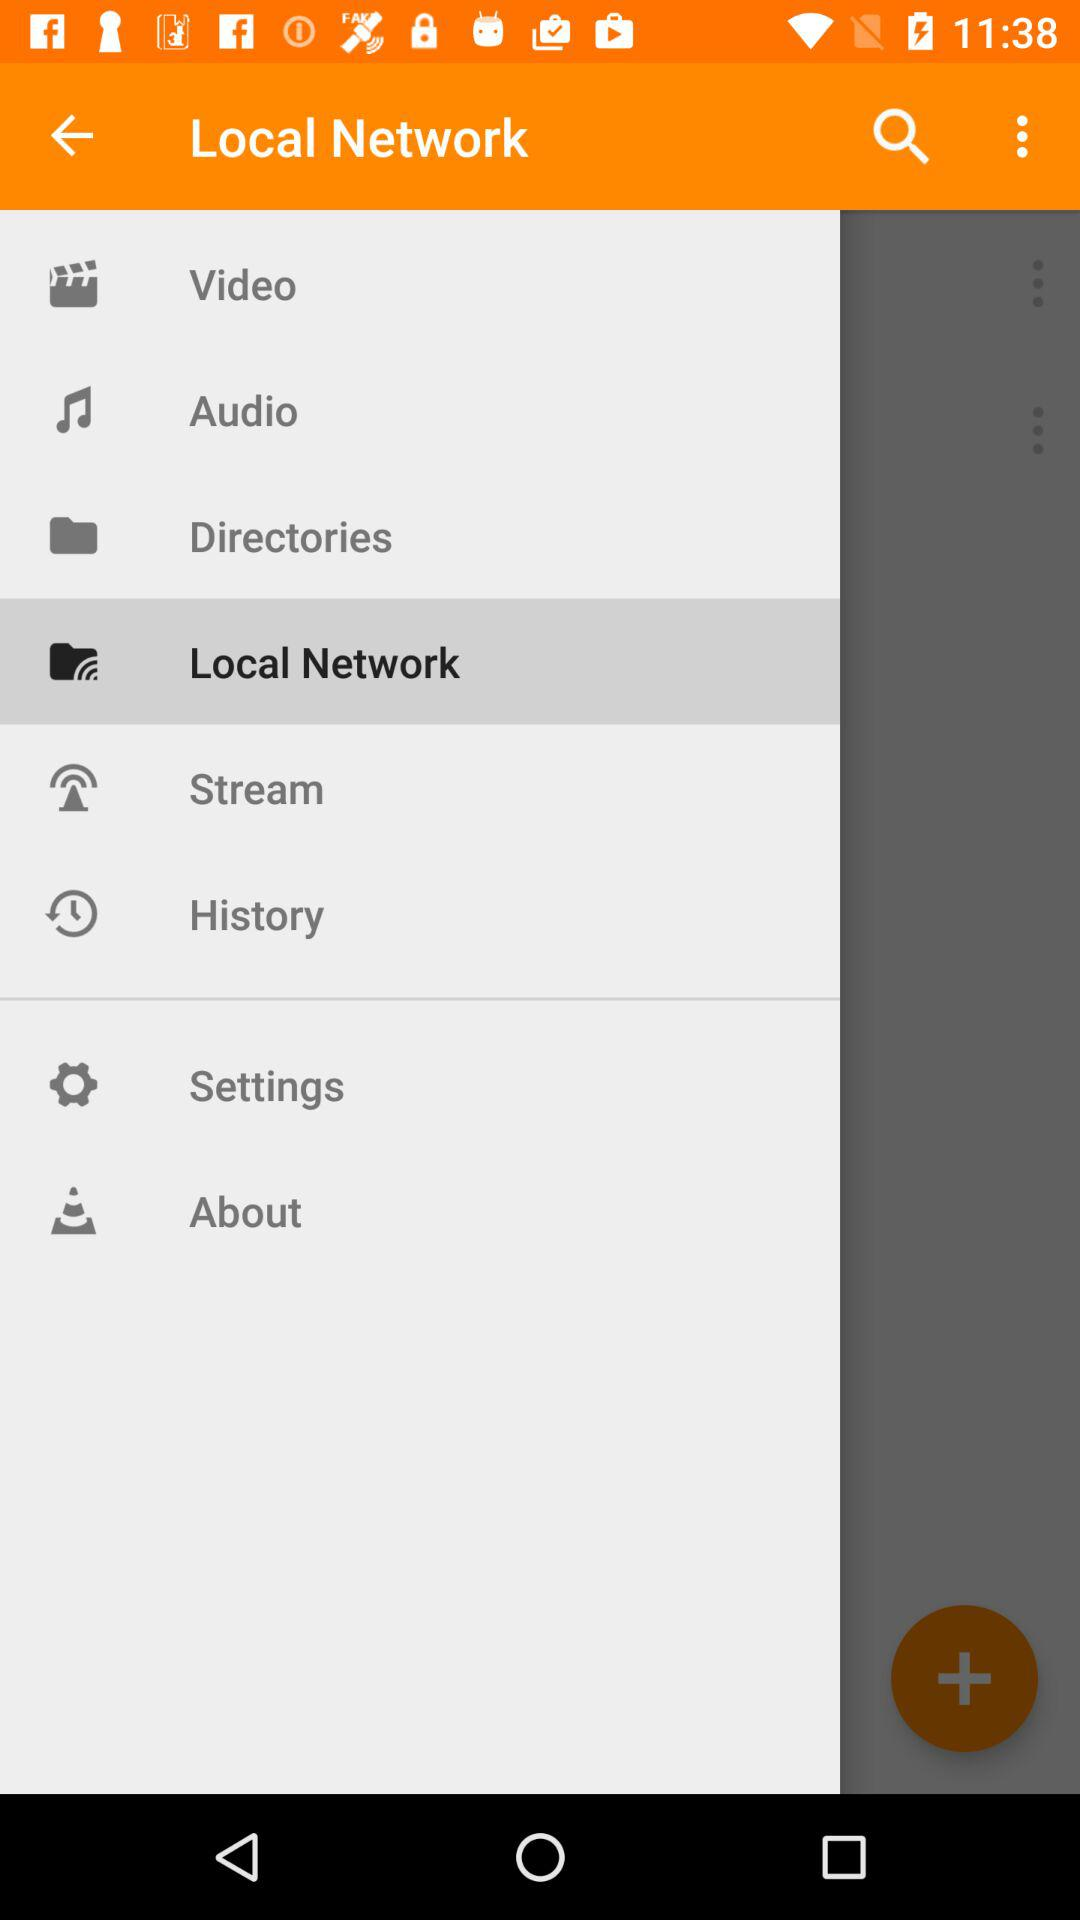What is the selected item in the menu? The selected item in the menu is "Local Network". 